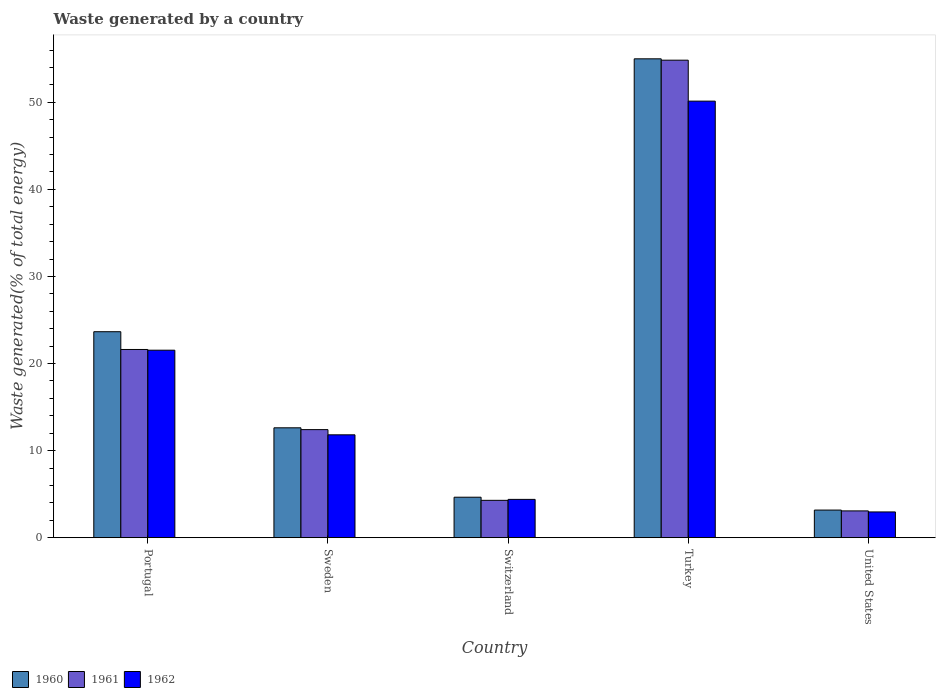How many groups of bars are there?
Make the answer very short. 5. Are the number of bars per tick equal to the number of legend labels?
Offer a very short reply. Yes. Are the number of bars on each tick of the X-axis equal?
Offer a terse response. Yes. How many bars are there on the 4th tick from the left?
Provide a succinct answer. 3. In how many cases, is the number of bars for a given country not equal to the number of legend labels?
Keep it short and to the point. 0. What is the total waste generated in 1962 in Portugal?
Your answer should be very brief. 21.53. Across all countries, what is the maximum total waste generated in 1962?
Your answer should be compact. 50.13. Across all countries, what is the minimum total waste generated in 1962?
Ensure brevity in your answer.  2.96. In which country was the total waste generated in 1960 maximum?
Keep it short and to the point. Turkey. In which country was the total waste generated in 1960 minimum?
Your answer should be very brief. United States. What is the total total waste generated in 1960 in the graph?
Provide a succinct answer. 99.1. What is the difference between the total waste generated in 1961 in Portugal and that in Sweden?
Give a very brief answer. 9.2. What is the difference between the total waste generated in 1962 in Switzerland and the total waste generated in 1960 in United States?
Make the answer very short. 1.23. What is the average total waste generated in 1962 per country?
Your response must be concise. 18.17. What is the difference between the total waste generated of/in 1962 and total waste generated of/in 1960 in Turkey?
Provide a succinct answer. -4.86. In how many countries, is the total waste generated in 1961 greater than 44 %?
Offer a very short reply. 1. What is the ratio of the total waste generated in 1961 in Portugal to that in Sweden?
Keep it short and to the point. 1.74. Is the total waste generated in 1962 in Switzerland less than that in United States?
Provide a succinct answer. No. Is the difference between the total waste generated in 1962 in Portugal and Turkey greater than the difference between the total waste generated in 1960 in Portugal and Turkey?
Your answer should be very brief. Yes. What is the difference between the highest and the second highest total waste generated in 1960?
Your answer should be compact. -42.37. What is the difference between the highest and the lowest total waste generated in 1960?
Offer a very short reply. 51.82. In how many countries, is the total waste generated in 1962 greater than the average total waste generated in 1962 taken over all countries?
Offer a terse response. 2. What does the 2nd bar from the left in Turkey represents?
Offer a terse response. 1961. How many countries are there in the graph?
Make the answer very short. 5. What is the difference between two consecutive major ticks on the Y-axis?
Provide a short and direct response. 10. Does the graph contain grids?
Your response must be concise. No. Where does the legend appear in the graph?
Your answer should be very brief. Bottom left. How are the legend labels stacked?
Offer a very short reply. Horizontal. What is the title of the graph?
Provide a succinct answer. Waste generated by a country. What is the label or title of the X-axis?
Offer a terse response. Country. What is the label or title of the Y-axis?
Keep it short and to the point. Waste generated(% of total energy). What is the Waste generated(% of total energy) of 1960 in Portugal?
Offer a very short reply. 23.66. What is the Waste generated(% of total energy) in 1961 in Portugal?
Your answer should be very brief. 21.62. What is the Waste generated(% of total energy) in 1962 in Portugal?
Your answer should be very brief. 21.53. What is the Waste generated(% of total energy) of 1960 in Sweden?
Your answer should be very brief. 12.62. What is the Waste generated(% of total energy) of 1961 in Sweden?
Your answer should be very brief. 12.41. What is the Waste generated(% of total energy) of 1962 in Sweden?
Your answer should be compact. 11.82. What is the Waste generated(% of total energy) in 1960 in Switzerland?
Offer a terse response. 4.65. What is the Waste generated(% of total energy) of 1961 in Switzerland?
Make the answer very short. 4.29. What is the Waste generated(% of total energy) in 1962 in Switzerland?
Give a very brief answer. 4.4. What is the Waste generated(% of total energy) in 1960 in Turkey?
Your answer should be compact. 54.99. What is the Waste generated(% of total energy) in 1961 in Turkey?
Give a very brief answer. 54.84. What is the Waste generated(% of total energy) in 1962 in Turkey?
Offer a terse response. 50.13. What is the Waste generated(% of total energy) of 1960 in United States?
Ensure brevity in your answer.  3.17. What is the Waste generated(% of total energy) of 1961 in United States?
Ensure brevity in your answer.  3.08. What is the Waste generated(% of total energy) of 1962 in United States?
Ensure brevity in your answer.  2.96. Across all countries, what is the maximum Waste generated(% of total energy) of 1960?
Offer a terse response. 54.99. Across all countries, what is the maximum Waste generated(% of total energy) of 1961?
Ensure brevity in your answer.  54.84. Across all countries, what is the maximum Waste generated(% of total energy) of 1962?
Offer a terse response. 50.13. Across all countries, what is the minimum Waste generated(% of total energy) of 1960?
Keep it short and to the point. 3.17. Across all countries, what is the minimum Waste generated(% of total energy) in 1961?
Make the answer very short. 3.08. Across all countries, what is the minimum Waste generated(% of total energy) of 1962?
Your answer should be compact. 2.96. What is the total Waste generated(% of total energy) in 1960 in the graph?
Ensure brevity in your answer.  99.1. What is the total Waste generated(% of total energy) in 1961 in the graph?
Provide a short and direct response. 96.24. What is the total Waste generated(% of total energy) of 1962 in the graph?
Your answer should be very brief. 90.85. What is the difference between the Waste generated(% of total energy) in 1960 in Portugal and that in Sweden?
Your answer should be compact. 11.03. What is the difference between the Waste generated(% of total energy) of 1961 in Portugal and that in Sweden?
Ensure brevity in your answer.  9.2. What is the difference between the Waste generated(% of total energy) in 1962 in Portugal and that in Sweden?
Offer a terse response. 9.72. What is the difference between the Waste generated(% of total energy) of 1960 in Portugal and that in Switzerland?
Your answer should be compact. 19.01. What is the difference between the Waste generated(% of total energy) in 1961 in Portugal and that in Switzerland?
Provide a short and direct response. 17.32. What is the difference between the Waste generated(% of total energy) of 1962 in Portugal and that in Switzerland?
Make the answer very short. 17.13. What is the difference between the Waste generated(% of total energy) in 1960 in Portugal and that in Turkey?
Ensure brevity in your answer.  -31.34. What is the difference between the Waste generated(% of total energy) in 1961 in Portugal and that in Turkey?
Your answer should be compact. -33.22. What is the difference between the Waste generated(% of total energy) in 1962 in Portugal and that in Turkey?
Your answer should be very brief. -28.6. What is the difference between the Waste generated(% of total energy) of 1960 in Portugal and that in United States?
Your answer should be compact. 20.48. What is the difference between the Waste generated(% of total energy) in 1961 in Portugal and that in United States?
Provide a succinct answer. 18.54. What is the difference between the Waste generated(% of total energy) in 1962 in Portugal and that in United States?
Provide a succinct answer. 18.57. What is the difference between the Waste generated(% of total energy) in 1960 in Sweden and that in Switzerland?
Offer a very short reply. 7.97. What is the difference between the Waste generated(% of total energy) in 1961 in Sweden and that in Switzerland?
Your answer should be very brief. 8.12. What is the difference between the Waste generated(% of total energy) in 1962 in Sweden and that in Switzerland?
Offer a very short reply. 7.41. What is the difference between the Waste generated(% of total energy) in 1960 in Sweden and that in Turkey?
Your answer should be very brief. -42.37. What is the difference between the Waste generated(% of total energy) in 1961 in Sweden and that in Turkey?
Provide a succinct answer. -42.43. What is the difference between the Waste generated(% of total energy) of 1962 in Sweden and that in Turkey?
Make the answer very short. -38.32. What is the difference between the Waste generated(% of total energy) of 1960 in Sweden and that in United States?
Ensure brevity in your answer.  9.45. What is the difference between the Waste generated(% of total energy) in 1961 in Sweden and that in United States?
Your answer should be very brief. 9.33. What is the difference between the Waste generated(% of total energy) in 1962 in Sweden and that in United States?
Ensure brevity in your answer.  8.86. What is the difference between the Waste generated(% of total energy) of 1960 in Switzerland and that in Turkey?
Offer a terse response. -50.34. What is the difference between the Waste generated(% of total energy) in 1961 in Switzerland and that in Turkey?
Provide a short and direct response. -50.55. What is the difference between the Waste generated(% of total energy) of 1962 in Switzerland and that in Turkey?
Provide a succinct answer. -45.73. What is the difference between the Waste generated(% of total energy) of 1960 in Switzerland and that in United States?
Ensure brevity in your answer.  1.48. What is the difference between the Waste generated(% of total energy) in 1961 in Switzerland and that in United States?
Make the answer very short. 1.21. What is the difference between the Waste generated(% of total energy) of 1962 in Switzerland and that in United States?
Your answer should be very brief. 1.44. What is the difference between the Waste generated(% of total energy) of 1960 in Turkey and that in United States?
Provide a succinct answer. 51.82. What is the difference between the Waste generated(% of total energy) in 1961 in Turkey and that in United States?
Make the answer very short. 51.76. What is the difference between the Waste generated(% of total energy) of 1962 in Turkey and that in United States?
Your answer should be compact. 47.17. What is the difference between the Waste generated(% of total energy) of 1960 in Portugal and the Waste generated(% of total energy) of 1961 in Sweden?
Provide a succinct answer. 11.24. What is the difference between the Waste generated(% of total energy) in 1960 in Portugal and the Waste generated(% of total energy) in 1962 in Sweden?
Your response must be concise. 11.84. What is the difference between the Waste generated(% of total energy) in 1961 in Portugal and the Waste generated(% of total energy) in 1962 in Sweden?
Keep it short and to the point. 9.8. What is the difference between the Waste generated(% of total energy) in 1960 in Portugal and the Waste generated(% of total energy) in 1961 in Switzerland?
Offer a terse response. 19.36. What is the difference between the Waste generated(% of total energy) of 1960 in Portugal and the Waste generated(% of total energy) of 1962 in Switzerland?
Ensure brevity in your answer.  19.25. What is the difference between the Waste generated(% of total energy) of 1961 in Portugal and the Waste generated(% of total energy) of 1962 in Switzerland?
Ensure brevity in your answer.  17.21. What is the difference between the Waste generated(% of total energy) in 1960 in Portugal and the Waste generated(% of total energy) in 1961 in Turkey?
Provide a short and direct response. -31.18. What is the difference between the Waste generated(% of total energy) of 1960 in Portugal and the Waste generated(% of total energy) of 1962 in Turkey?
Ensure brevity in your answer.  -26.48. What is the difference between the Waste generated(% of total energy) of 1961 in Portugal and the Waste generated(% of total energy) of 1962 in Turkey?
Ensure brevity in your answer.  -28.52. What is the difference between the Waste generated(% of total energy) in 1960 in Portugal and the Waste generated(% of total energy) in 1961 in United States?
Your answer should be compact. 20.58. What is the difference between the Waste generated(% of total energy) in 1960 in Portugal and the Waste generated(% of total energy) in 1962 in United States?
Offer a terse response. 20.7. What is the difference between the Waste generated(% of total energy) of 1961 in Portugal and the Waste generated(% of total energy) of 1962 in United States?
Offer a terse response. 18.66. What is the difference between the Waste generated(% of total energy) of 1960 in Sweden and the Waste generated(% of total energy) of 1961 in Switzerland?
Your answer should be compact. 8.33. What is the difference between the Waste generated(% of total energy) in 1960 in Sweden and the Waste generated(% of total energy) in 1962 in Switzerland?
Your response must be concise. 8.22. What is the difference between the Waste generated(% of total energy) in 1961 in Sweden and the Waste generated(% of total energy) in 1962 in Switzerland?
Provide a short and direct response. 8.01. What is the difference between the Waste generated(% of total energy) of 1960 in Sweden and the Waste generated(% of total energy) of 1961 in Turkey?
Make the answer very short. -42.22. What is the difference between the Waste generated(% of total energy) in 1960 in Sweden and the Waste generated(% of total energy) in 1962 in Turkey?
Provide a succinct answer. -37.51. What is the difference between the Waste generated(% of total energy) of 1961 in Sweden and the Waste generated(% of total energy) of 1962 in Turkey?
Give a very brief answer. -37.72. What is the difference between the Waste generated(% of total energy) in 1960 in Sweden and the Waste generated(% of total energy) in 1961 in United States?
Make the answer very short. 9.54. What is the difference between the Waste generated(% of total energy) of 1960 in Sweden and the Waste generated(% of total energy) of 1962 in United States?
Offer a very short reply. 9.66. What is the difference between the Waste generated(% of total energy) of 1961 in Sweden and the Waste generated(% of total energy) of 1962 in United States?
Keep it short and to the point. 9.45. What is the difference between the Waste generated(% of total energy) in 1960 in Switzerland and the Waste generated(% of total energy) in 1961 in Turkey?
Your answer should be compact. -50.19. What is the difference between the Waste generated(% of total energy) in 1960 in Switzerland and the Waste generated(% of total energy) in 1962 in Turkey?
Provide a short and direct response. -45.48. What is the difference between the Waste generated(% of total energy) in 1961 in Switzerland and the Waste generated(% of total energy) in 1962 in Turkey?
Offer a terse response. -45.84. What is the difference between the Waste generated(% of total energy) of 1960 in Switzerland and the Waste generated(% of total energy) of 1961 in United States?
Provide a short and direct response. 1.57. What is the difference between the Waste generated(% of total energy) of 1960 in Switzerland and the Waste generated(% of total energy) of 1962 in United States?
Your response must be concise. 1.69. What is the difference between the Waste generated(% of total energy) of 1961 in Switzerland and the Waste generated(% of total energy) of 1962 in United States?
Ensure brevity in your answer.  1.33. What is the difference between the Waste generated(% of total energy) in 1960 in Turkey and the Waste generated(% of total energy) in 1961 in United States?
Provide a succinct answer. 51.92. What is the difference between the Waste generated(% of total energy) in 1960 in Turkey and the Waste generated(% of total energy) in 1962 in United States?
Ensure brevity in your answer.  52.03. What is the difference between the Waste generated(% of total energy) in 1961 in Turkey and the Waste generated(% of total energy) in 1962 in United States?
Give a very brief answer. 51.88. What is the average Waste generated(% of total energy) of 1960 per country?
Offer a very short reply. 19.82. What is the average Waste generated(% of total energy) in 1961 per country?
Provide a short and direct response. 19.25. What is the average Waste generated(% of total energy) in 1962 per country?
Ensure brevity in your answer.  18.17. What is the difference between the Waste generated(% of total energy) of 1960 and Waste generated(% of total energy) of 1961 in Portugal?
Your response must be concise. 2.04. What is the difference between the Waste generated(% of total energy) of 1960 and Waste generated(% of total energy) of 1962 in Portugal?
Your response must be concise. 2.12. What is the difference between the Waste generated(% of total energy) of 1961 and Waste generated(% of total energy) of 1962 in Portugal?
Offer a very short reply. 0.08. What is the difference between the Waste generated(% of total energy) of 1960 and Waste generated(% of total energy) of 1961 in Sweden?
Keep it short and to the point. 0.21. What is the difference between the Waste generated(% of total energy) in 1960 and Waste generated(% of total energy) in 1962 in Sweden?
Offer a very short reply. 0.81. What is the difference between the Waste generated(% of total energy) of 1961 and Waste generated(% of total energy) of 1962 in Sweden?
Give a very brief answer. 0.6. What is the difference between the Waste generated(% of total energy) in 1960 and Waste generated(% of total energy) in 1961 in Switzerland?
Provide a succinct answer. 0.36. What is the difference between the Waste generated(% of total energy) in 1960 and Waste generated(% of total energy) in 1962 in Switzerland?
Offer a very short reply. 0.25. What is the difference between the Waste generated(% of total energy) in 1961 and Waste generated(% of total energy) in 1962 in Switzerland?
Provide a succinct answer. -0.11. What is the difference between the Waste generated(% of total energy) in 1960 and Waste generated(% of total energy) in 1961 in Turkey?
Provide a short and direct response. 0.16. What is the difference between the Waste generated(% of total energy) in 1960 and Waste generated(% of total energy) in 1962 in Turkey?
Your answer should be compact. 4.86. What is the difference between the Waste generated(% of total energy) in 1961 and Waste generated(% of total energy) in 1962 in Turkey?
Your response must be concise. 4.7. What is the difference between the Waste generated(% of total energy) in 1960 and Waste generated(% of total energy) in 1961 in United States?
Give a very brief answer. 0.1. What is the difference between the Waste generated(% of total energy) of 1960 and Waste generated(% of total energy) of 1962 in United States?
Your response must be concise. 0.21. What is the difference between the Waste generated(% of total energy) in 1961 and Waste generated(% of total energy) in 1962 in United States?
Keep it short and to the point. 0.12. What is the ratio of the Waste generated(% of total energy) in 1960 in Portugal to that in Sweden?
Ensure brevity in your answer.  1.87. What is the ratio of the Waste generated(% of total energy) of 1961 in Portugal to that in Sweden?
Your response must be concise. 1.74. What is the ratio of the Waste generated(% of total energy) of 1962 in Portugal to that in Sweden?
Ensure brevity in your answer.  1.82. What is the ratio of the Waste generated(% of total energy) of 1960 in Portugal to that in Switzerland?
Make the answer very short. 5.09. What is the ratio of the Waste generated(% of total energy) of 1961 in Portugal to that in Switzerland?
Your response must be concise. 5.04. What is the ratio of the Waste generated(% of total energy) in 1962 in Portugal to that in Switzerland?
Your answer should be compact. 4.89. What is the ratio of the Waste generated(% of total energy) of 1960 in Portugal to that in Turkey?
Ensure brevity in your answer.  0.43. What is the ratio of the Waste generated(% of total energy) in 1961 in Portugal to that in Turkey?
Your response must be concise. 0.39. What is the ratio of the Waste generated(% of total energy) in 1962 in Portugal to that in Turkey?
Ensure brevity in your answer.  0.43. What is the ratio of the Waste generated(% of total energy) of 1960 in Portugal to that in United States?
Offer a very short reply. 7.45. What is the ratio of the Waste generated(% of total energy) of 1961 in Portugal to that in United States?
Your answer should be compact. 7.02. What is the ratio of the Waste generated(% of total energy) in 1962 in Portugal to that in United States?
Your answer should be compact. 7.27. What is the ratio of the Waste generated(% of total energy) of 1960 in Sweden to that in Switzerland?
Your response must be concise. 2.71. What is the ratio of the Waste generated(% of total energy) in 1961 in Sweden to that in Switzerland?
Keep it short and to the point. 2.89. What is the ratio of the Waste generated(% of total energy) in 1962 in Sweden to that in Switzerland?
Provide a succinct answer. 2.68. What is the ratio of the Waste generated(% of total energy) of 1960 in Sweden to that in Turkey?
Your response must be concise. 0.23. What is the ratio of the Waste generated(% of total energy) in 1961 in Sweden to that in Turkey?
Ensure brevity in your answer.  0.23. What is the ratio of the Waste generated(% of total energy) of 1962 in Sweden to that in Turkey?
Keep it short and to the point. 0.24. What is the ratio of the Waste generated(% of total energy) of 1960 in Sweden to that in United States?
Give a very brief answer. 3.98. What is the ratio of the Waste generated(% of total energy) in 1961 in Sweden to that in United States?
Offer a terse response. 4.03. What is the ratio of the Waste generated(% of total energy) in 1962 in Sweden to that in United States?
Offer a terse response. 3.99. What is the ratio of the Waste generated(% of total energy) in 1960 in Switzerland to that in Turkey?
Offer a terse response. 0.08. What is the ratio of the Waste generated(% of total energy) in 1961 in Switzerland to that in Turkey?
Your response must be concise. 0.08. What is the ratio of the Waste generated(% of total energy) in 1962 in Switzerland to that in Turkey?
Your answer should be compact. 0.09. What is the ratio of the Waste generated(% of total energy) of 1960 in Switzerland to that in United States?
Your response must be concise. 1.46. What is the ratio of the Waste generated(% of total energy) in 1961 in Switzerland to that in United States?
Ensure brevity in your answer.  1.39. What is the ratio of the Waste generated(% of total energy) of 1962 in Switzerland to that in United States?
Give a very brief answer. 1.49. What is the ratio of the Waste generated(% of total energy) of 1960 in Turkey to that in United States?
Provide a succinct answer. 17.32. What is the ratio of the Waste generated(% of total energy) in 1961 in Turkey to that in United States?
Provide a short and direct response. 17.81. What is the ratio of the Waste generated(% of total energy) in 1962 in Turkey to that in United States?
Make the answer very short. 16.94. What is the difference between the highest and the second highest Waste generated(% of total energy) in 1960?
Your response must be concise. 31.34. What is the difference between the highest and the second highest Waste generated(% of total energy) of 1961?
Make the answer very short. 33.22. What is the difference between the highest and the second highest Waste generated(% of total energy) in 1962?
Give a very brief answer. 28.6. What is the difference between the highest and the lowest Waste generated(% of total energy) in 1960?
Offer a very short reply. 51.82. What is the difference between the highest and the lowest Waste generated(% of total energy) in 1961?
Your answer should be compact. 51.76. What is the difference between the highest and the lowest Waste generated(% of total energy) of 1962?
Offer a very short reply. 47.17. 